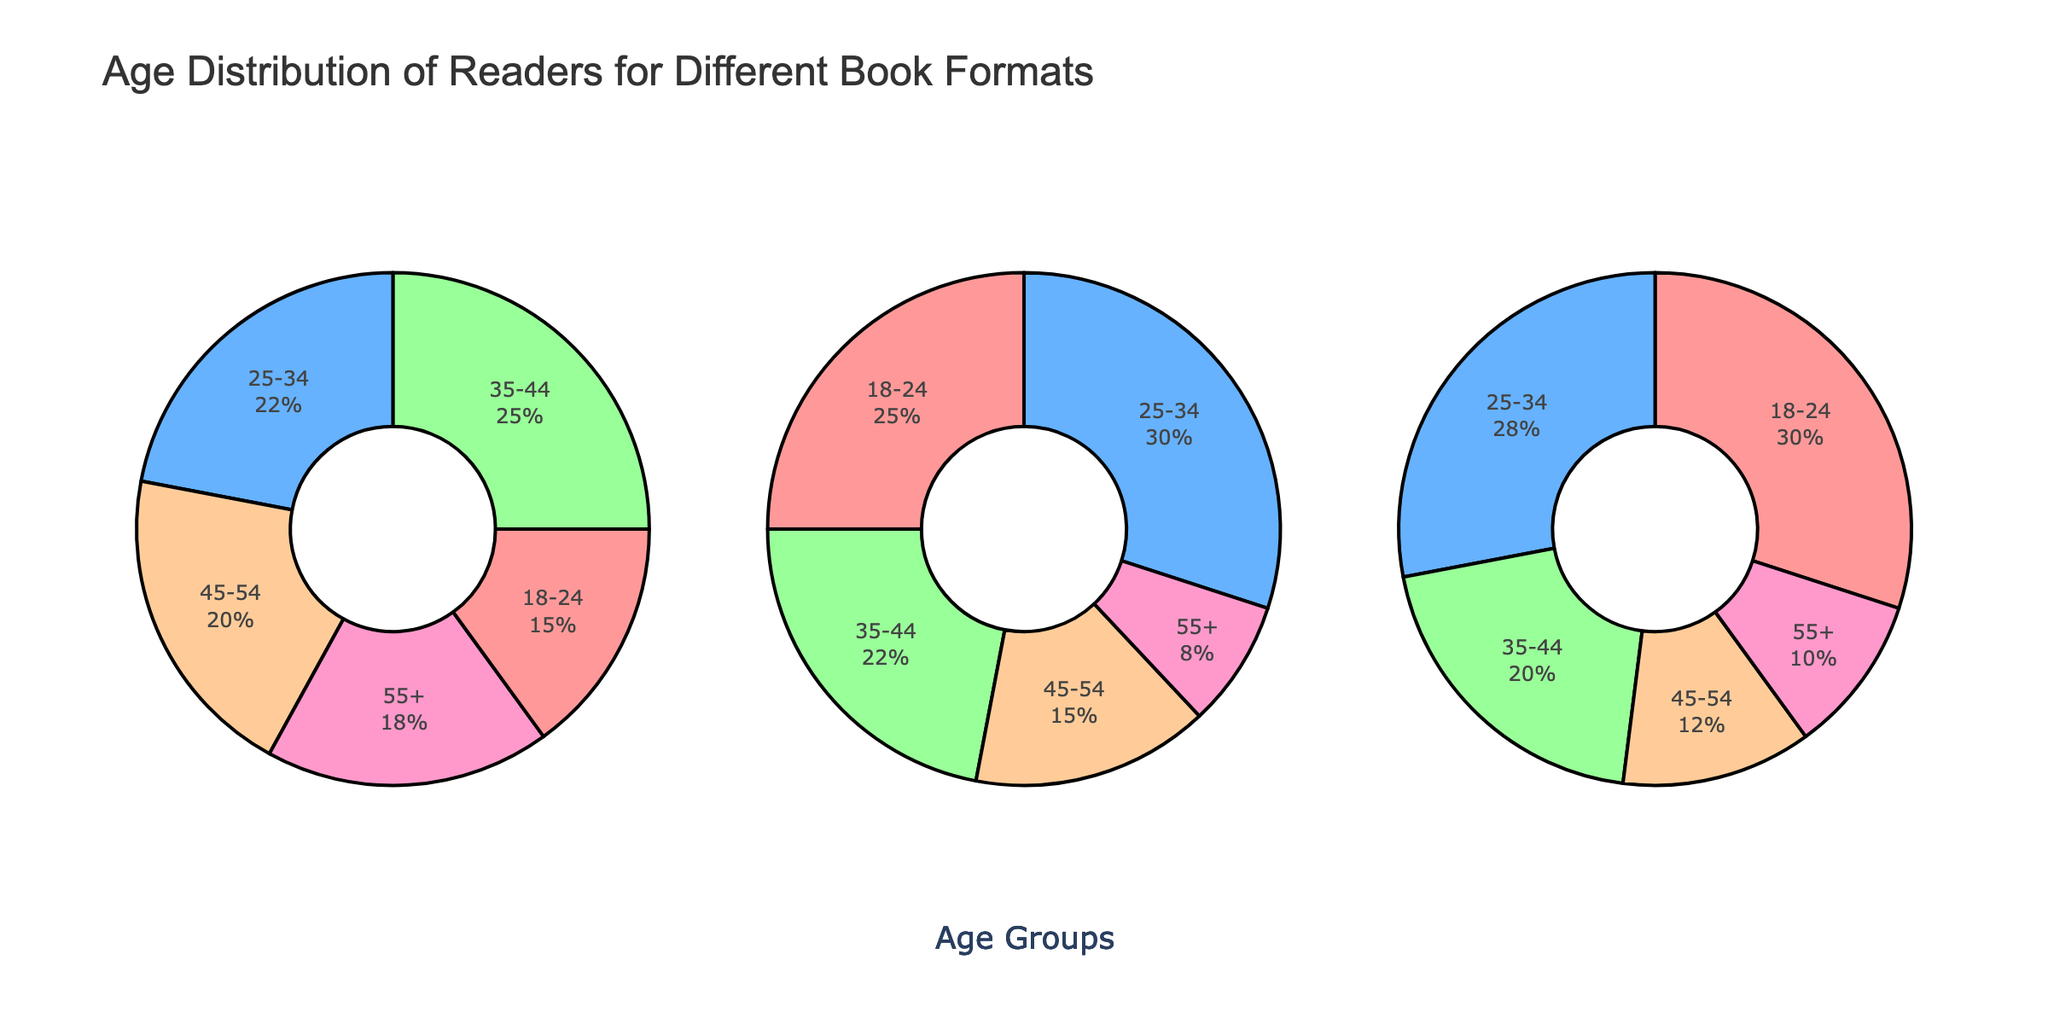What is the title of the plot? The title is indicated at the top of the figure to describe the content represented in the subplots. In this case, it details the primary focus of the plot.
Answer: Age Distribution of Readers for Different Book Formats Which age group has the highest percentage for print books? By interpreting the pie chart titled "Print Books," we can look at the segment that occupies the largest proportion of the pie.
Answer: 35-44 How do the percentages of the 18-24 age group for e-books and audiobooks compare? Refer to the percentage segments for the 18-24 age group in both "E-books" and "Audiobooks" subplots. The segment for e-books is smaller than the segment for audiobooks.
Answer: Audiobooks have a higher percentage What is the combined percentage of readers aged 45-54 and 55+ for print books? Sum the percentages of the 45-54 age group and the 55+ age group from the "Print Books" pie chart.
Answer: 38% Which format has the most even distribution of age groups? Examine the pie charts to compare how evenly the segments are distributed across all age groups for each format. Audiobooks show a more even distribution without any single age group dominating.
Answer: Audiobooks What is the difference in percentage of the 25-34 age group between e-books and print books? Calculate the percentage of the 25-34 age group for both e-books and print books and find the difference. E-books: 30%, Print books: 22%
Answer: 8% Which age group has the lowest percentage of readers for audiobooks? Find the segment in the "Audiobooks" pie chart that occupies the smallest proportion.
Answer: 45-54 For which format are the 18-24 age group readers most dominant? Why? Identify the format where the 18-24 age group segment is the largest compared to other formats. This can be seen in the "Audiobooks" subplot, where the 18-24 segment is the largest relative to the other age groups.
Answer: Audiobooks What is the percentage difference of the oldest age group (55+) between print books and e-books? Find the percentages for the 55+ age group in the "Print Books" and "E-books" subplots and calculate the difference. Print books: 18%, E-books: 8%
Answer: 10% Which format attracts the youngest readers (18-24) the most? Look for the pie chart where the 18-24 age group segment is the largest among the given age groups for each format.
Answer: Audiobooks 